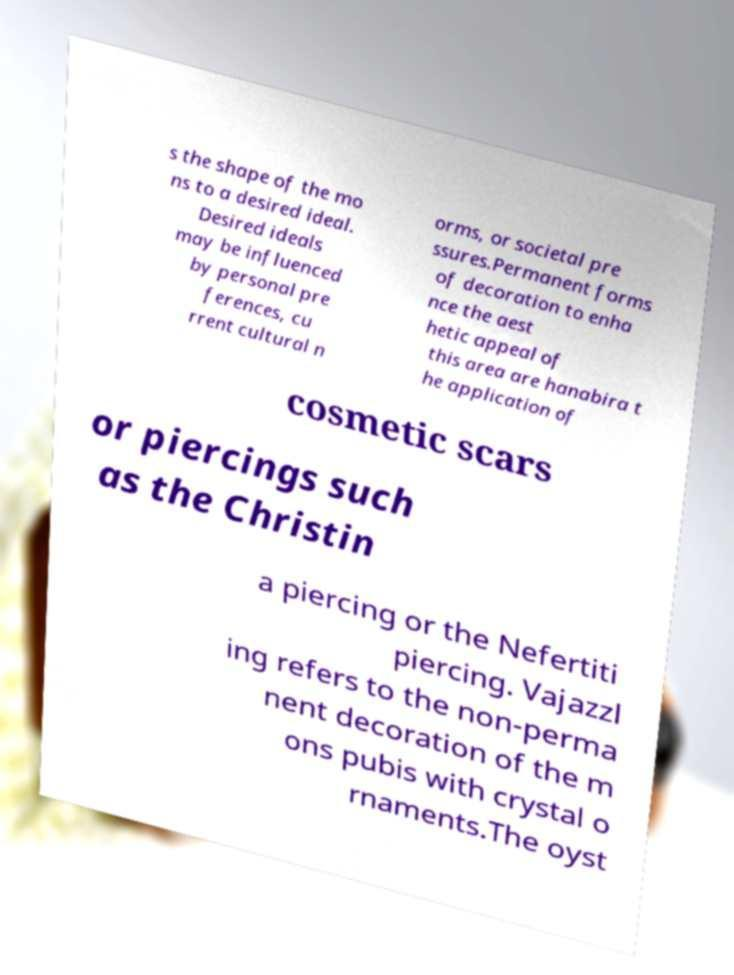Can you accurately transcribe the text from the provided image for me? s the shape of the mo ns to a desired ideal. Desired ideals may be influenced by personal pre ferences, cu rrent cultural n orms, or societal pre ssures.Permanent forms of decoration to enha nce the aest hetic appeal of this area are hanabira t he application of cosmetic scars or piercings such as the Christin a piercing or the Nefertiti piercing. Vajazzl ing refers to the non-perma nent decoration of the m ons pubis with crystal o rnaments.The oyst 